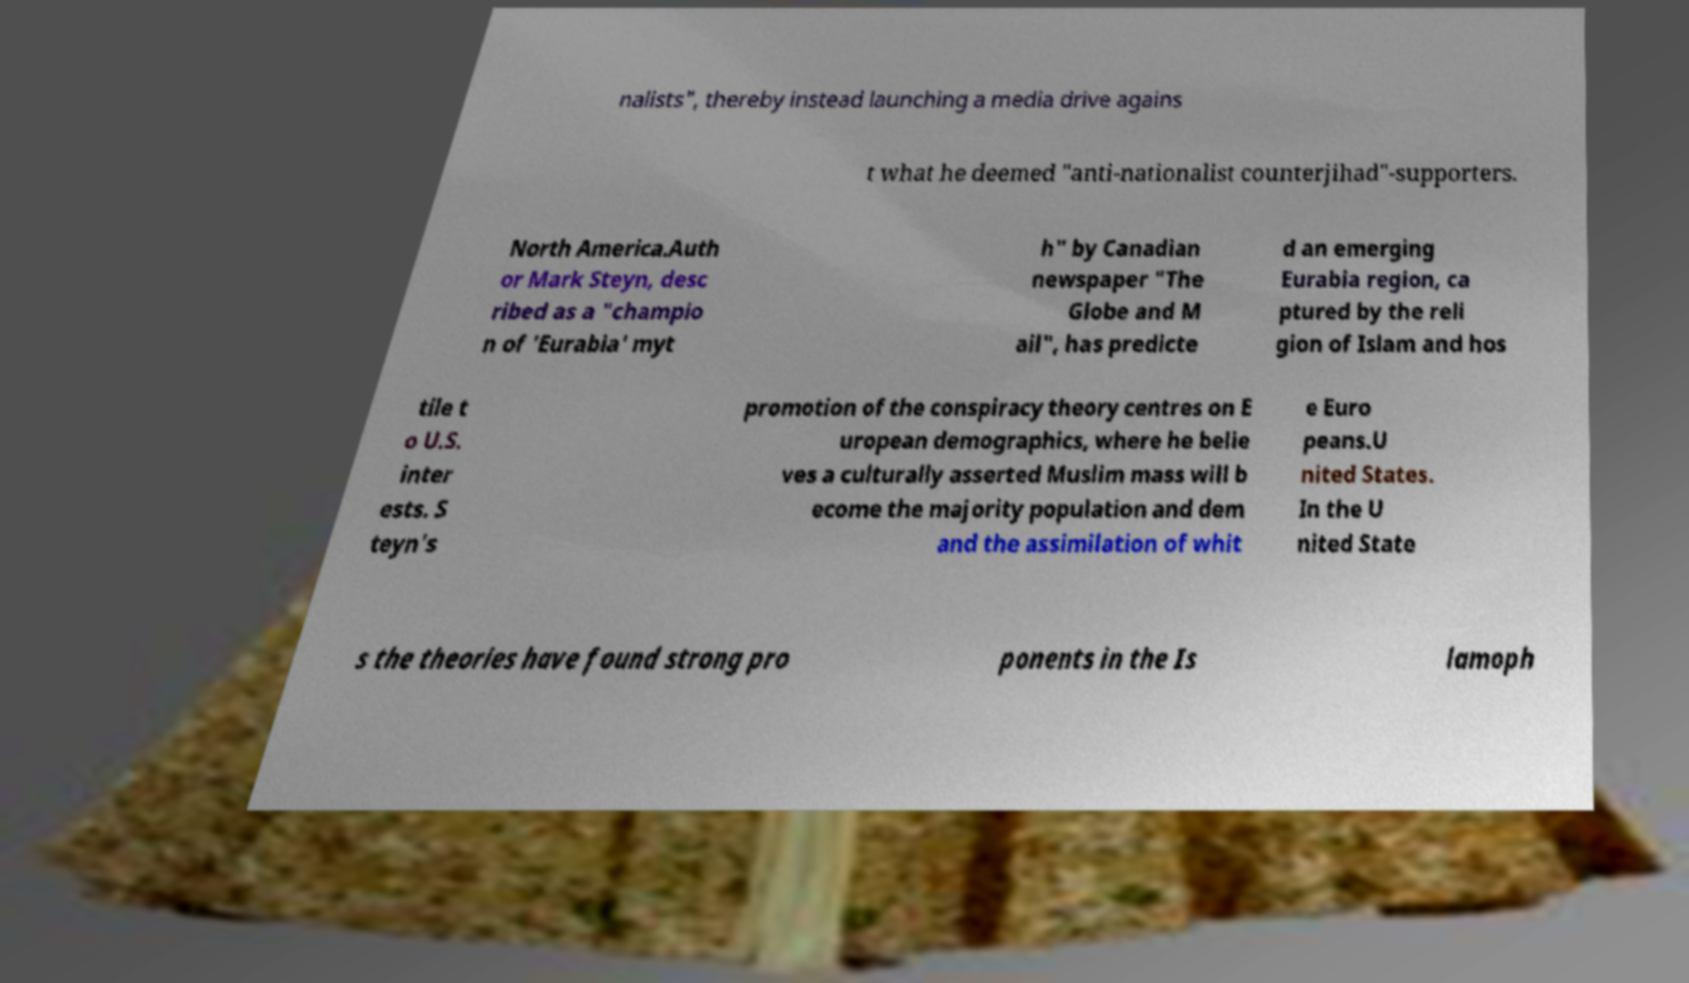There's text embedded in this image that I need extracted. Can you transcribe it verbatim? nalists", thereby instead launching a media drive agains t what he deemed "anti-nationalist counterjihad"-supporters. North America.Auth or Mark Steyn, desc ribed as a "champio n of 'Eurabia' myt h" by Canadian newspaper "The Globe and M ail", has predicte d an emerging Eurabia region, ca ptured by the reli gion of Islam and hos tile t o U.S. inter ests. S teyn's promotion of the conspiracy theory centres on E uropean demographics, where he belie ves a culturally asserted Muslim mass will b ecome the majority population and dem and the assimilation of whit e Euro peans.U nited States. In the U nited State s the theories have found strong pro ponents in the Is lamoph 